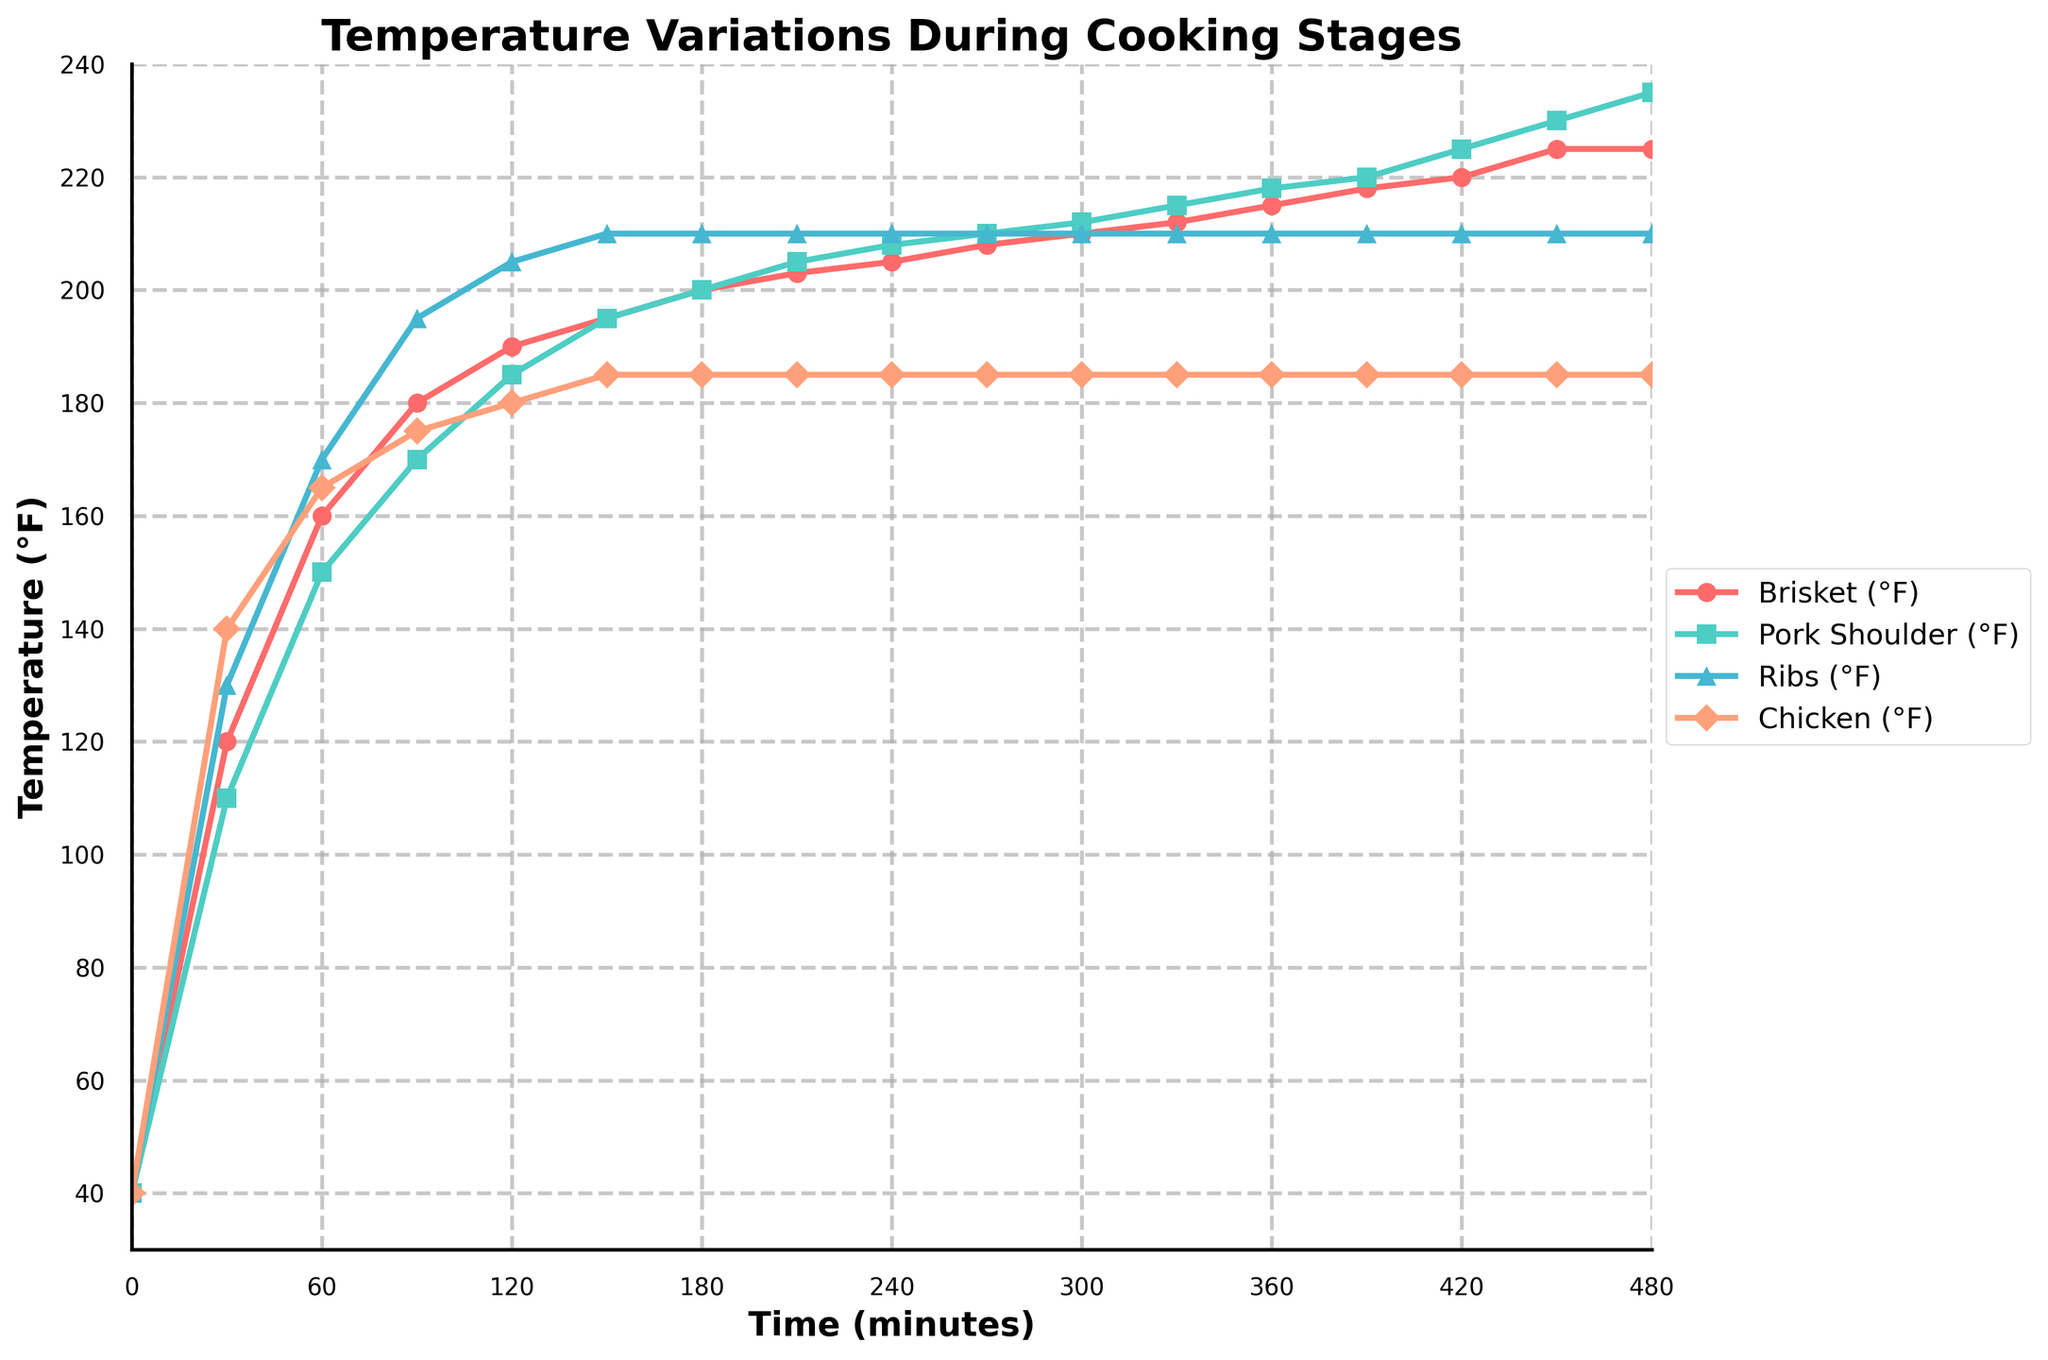What's the highest temperature reached by Brisket during the cooking stages? The highest temperature for the Brisket line is at the very end of the plot. Referencing the final value on the y-axis for the red line (Brisket).
Answer: 225°F Which meat reaches 185°F first, and at what time does this occur? Both Ribs and Chicken reach 185°F, but Chicken reaches it earlier. Chicken hits 185°F between 90 and 120 minutes. Referencing the green (Chicken) and purple (Ribs) lines shows Chicken hits 185°F at 90 to 120 minutes.
Answer: Chicken, 120 minutes What's the temperature difference between Brisket and Pork Shoulder at 180 minutes? Brisket's temperature at 180 minutes is 200°F, and Pork Shoulder is 200°F. The difference is the absolute value of (200 - 200).
Answer: 0°F Considering time intervals of 90 minutes, what is the average temperature increase for Ribs from 90 to 270 minutes? Ribs' temperature at 90 minutes is 195°F, and at 270 minutes, it is 210°F. The increase is (210 - 195), and average increment per 90 minutes is (15/3) because the interval is 3*90 minutes.
Answer: 5°F per 90 minutes How does the heating rate of Chicken change after 120 minutes? Up to 120 minutes, Chicken temperature rises quickly; from 180 minutes to 480 minutes, the rate is constant and much slower (temperature stays at 185°F). This is seen as a flattening of the green line post-120 minutes.
Answer: Drastically decreased Which meat consistently has the highest temperature throughout the cooking process? By comparing the vertical positions of the lines across the time duration, Chicken (green) most often lies above others until 210 minutes, making it the highest initially.
Answer: Chicken How much time does it take for Pork Shoulder to reach its highest temperature? Pork Shoulder reaches the highest temperature (235°F) at 480 minutes. Observing the highest point for the cyan line tells this.
Answer: 480 minutes What is the temperature difference between Ribs and Chicken at 240 minutes? At 240 minutes, Ribs are at 210°F and Chicken at 185°F. The difference is (210 - 185).
Answer: 25°F Among the meats, which two maintain the closest temperatures between 180 and 300 minutes? From 180 to 300 minutes, Brisket and Pork Shoulder temperatures are very close (both around 200-210°F). Referring to red and cyan lines in that interval.
Answer: Brisket and Pork Shoulder Which visual feature indicates that Chicken temperature stabilizes earlier than others? The Chicken line (green) flattens earliest at around 180 minutes and remains horizontal compared to others, indicating a stop in temperature rise.
Answer: Flattened line for Chicken 